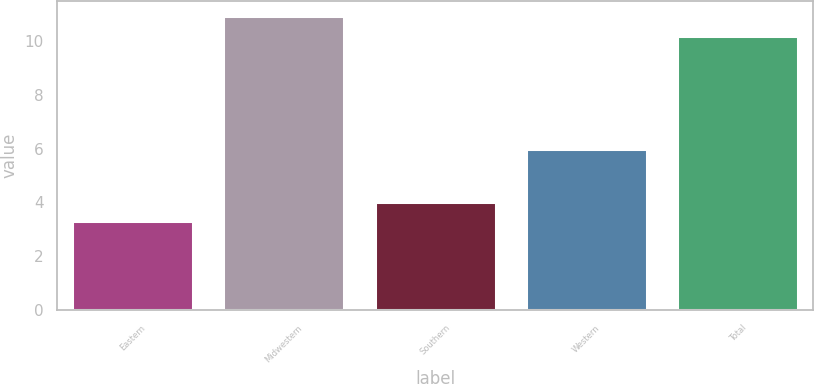Convert chart to OTSL. <chart><loc_0><loc_0><loc_500><loc_500><bar_chart><fcel>Eastern<fcel>Midwestern<fcel>Southern<fcel>Western<fcel>Total<nl><fcel>3.3<fcel>10.93<fcel>4.03<fcel>6<fcel>10.2<nl></chart> 